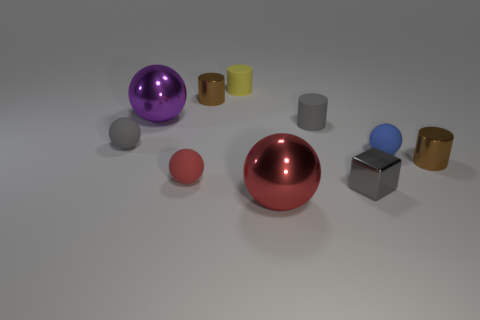Subtract 2 balls. How many balls are left? 3 Subtract all tiny gray rubber spheres. How many spheres are left? 4 Subtract all cyan spheres. Subtract all yellow cubes. How many spheres are left? 5 Subtract all cylinders. How many objects are left? 6 Add 6 gray blocks. How many gray blocks exist? 7 Subtract 0 red cubes. How many objects are left? 10 Subtract all large red things. Subtract all small blocks. How many objects are left? 8 Add 1 small brown metallic objects. How many small brown metallic objects are left? 3 